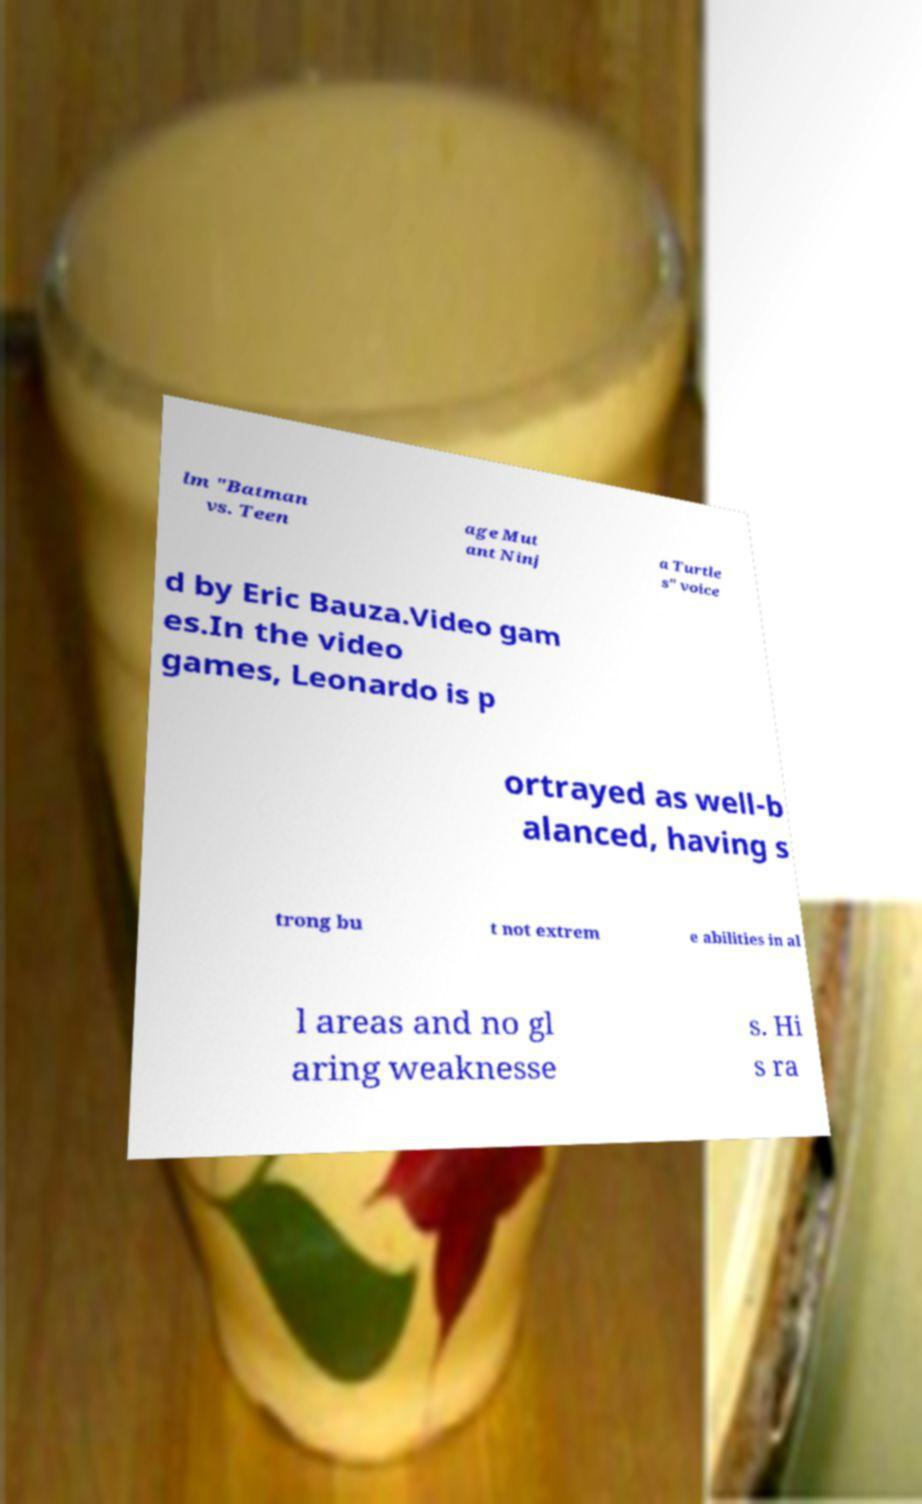What messages or text are displayed in this image? I need them in a readable, typed format. lm "Batman vs. Teen age Mut ant Ninj a Turtle s" voice d by Eric Bauza.Video gam es.In the video games, Leonardo is p ortrayed as well-b alanced, having s trong bu t not extrem e abilities in al l areas and no gl aring weaknesse s. Hi s ra 